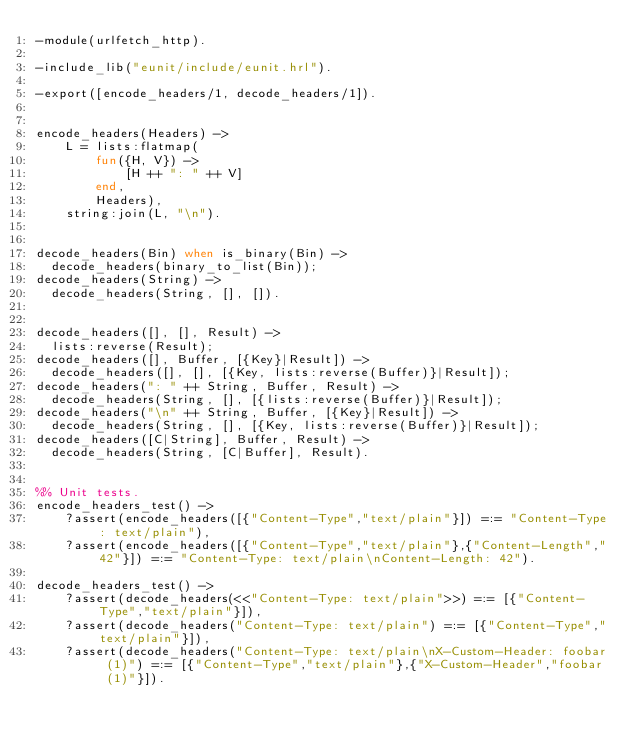<code> <loc_0><loc_0><loc_500><loc_500><_Erlang_>-module(urlfetch_http).

-include_lib("eunit/include/eunit.hrl").

-export([encode_headers/1, decode_headers/1]).


encode_headers(Headers) ->
    L = lists:flatmap(
        fun({H, V}) -> 
            [H ++ ": " ++ V]
        end,
        Headers),
    string:join(L, "\n").


decode_headers(Bin) when is_binary(Bin) ->
  decode_headers(binary_to_list(Bin));
decode_headers(String) ->
  decode_headers(String, [], []).


decode_headers([], [], Result) ->
  lists:reverse(Result);
decode_headers([], Buffer, [{Key}|Result]) ->
  decode_headers([], [], [{Key, lists:reverse(Buffer)}|Result]);
decode_headers(": " ++ String, Buffer, Result) ->
  decode_headers(String, [], [{lists:reverse(Buffer)}|Result]);
decode_headers("\n" ++ String, Buffer, [{Key}|Result]) ->
  decode_headers(String, [], [{Key, lists:reverse(Buffer)}|Result]);
decode_headers([C|String], Buffer, Result) ->
  decode_headers(String, [C|Buffer], Result).


%% Unit tests.
encode_headers_test() ->
    ?assert(encode_headers([{"Content-Type","text/plain"}]) =:= "Content-Type: text/plain"),
    ?assert(encode_headers([{"Content-Type","text/plain"},{"Content-Length","42"}]) =:= "Content-Type: text/plain\nContent-Length: 42").

decode_headers_test() ->
    ?assert(decode_headers(<<"Content-Type: text/plain">>) =:= [{"Content-Type","text/plain"}]),
    ?assert(decode_headers("Content-Type: text/plain") =:= [{"Content-Type","text/plain"}]),
    ?assert(decode_headers("Content-Type: text/plain\nX-Custom-Header: foobar (1)") =:= [{"Content-Type","text/plain"},{"X-Custom-Header","foobar (1)"}]).
</code> 